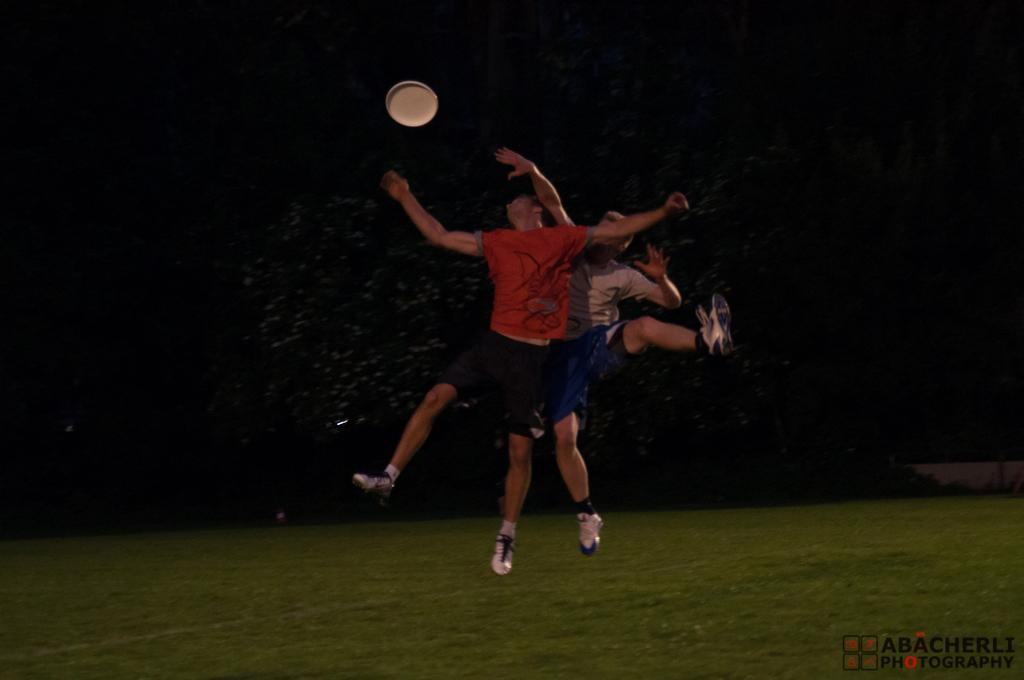How many people are in the image? There are two men in the middle of the picture. What is happening with the disk in the image? There is a disk in the air in the top of the picture. What is the color of the background in the image? The background of the image is dark. What town is being shown in the image? There is no town visible in the image; it only features two men and a disk in the air. 